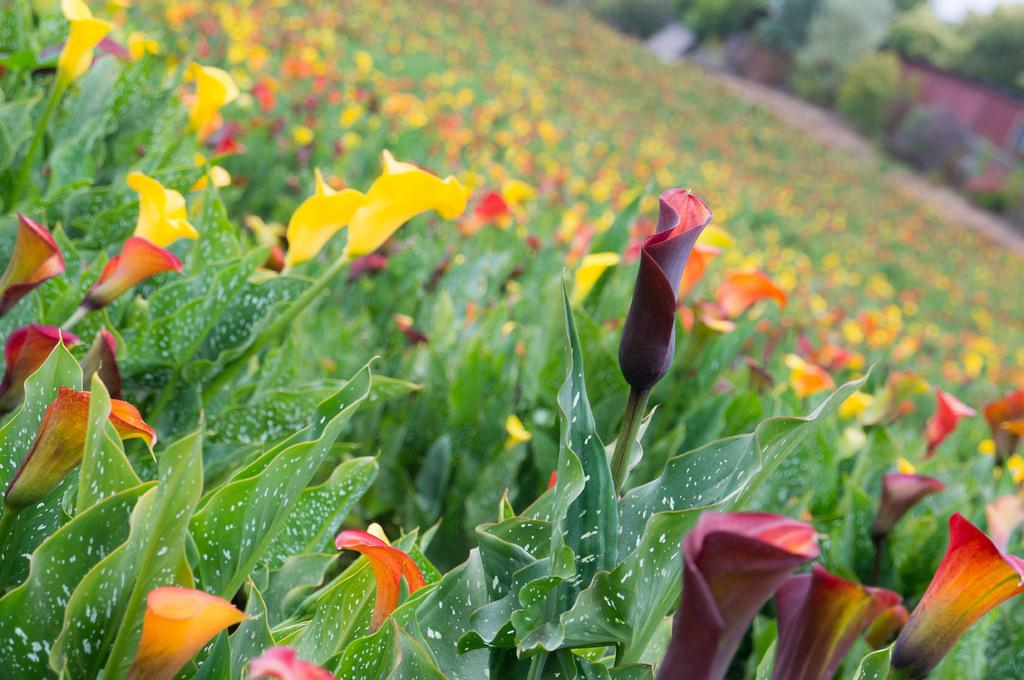What type of plants can be seen in the image? There are flowers and leaves in the image. What can be seen in the background of the image? There are trees in the background of the image. How would you describe the appearance of the background? The background of the image is blurry. Where is the bomb hidden among the flowers in the image? There is no bomb present in the image; it only features flowers, leaves, and trees. What type of sticks can be seen in the image? There are no sticks visible in the image. 